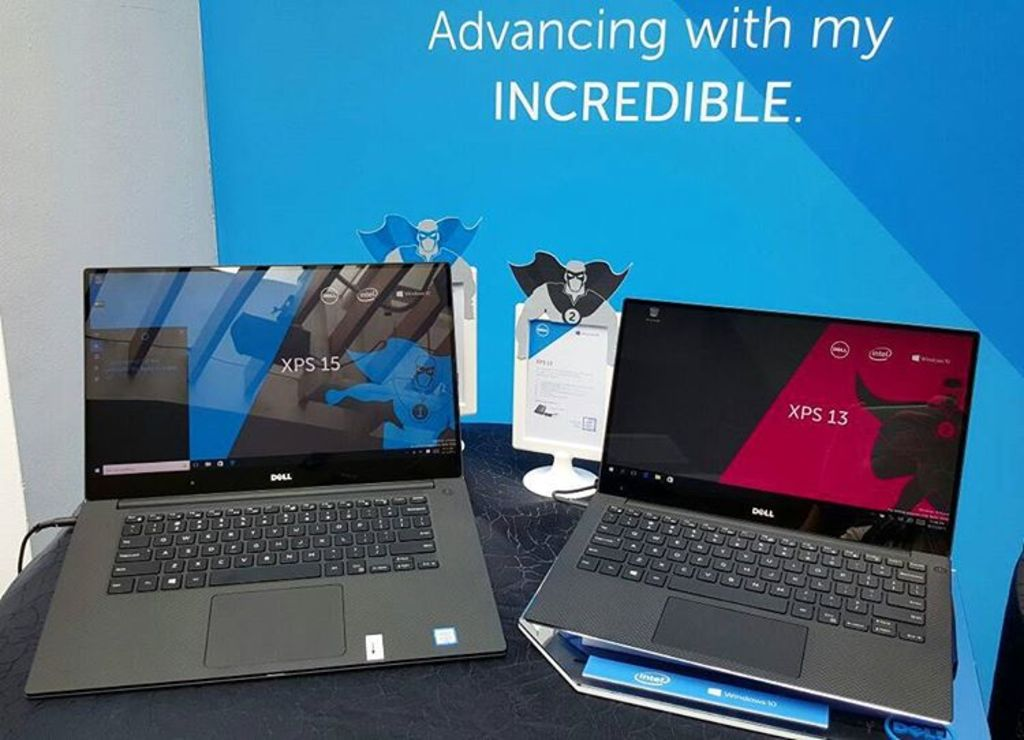Provide a one-sentence caption for the provided image. Two high-performance Dell laptops, the XPS 15 and XPS 13, are displayed on a desk against a backdrop of a promotional banner exclaiming 'Advancing with my INCREDIBLE.' 